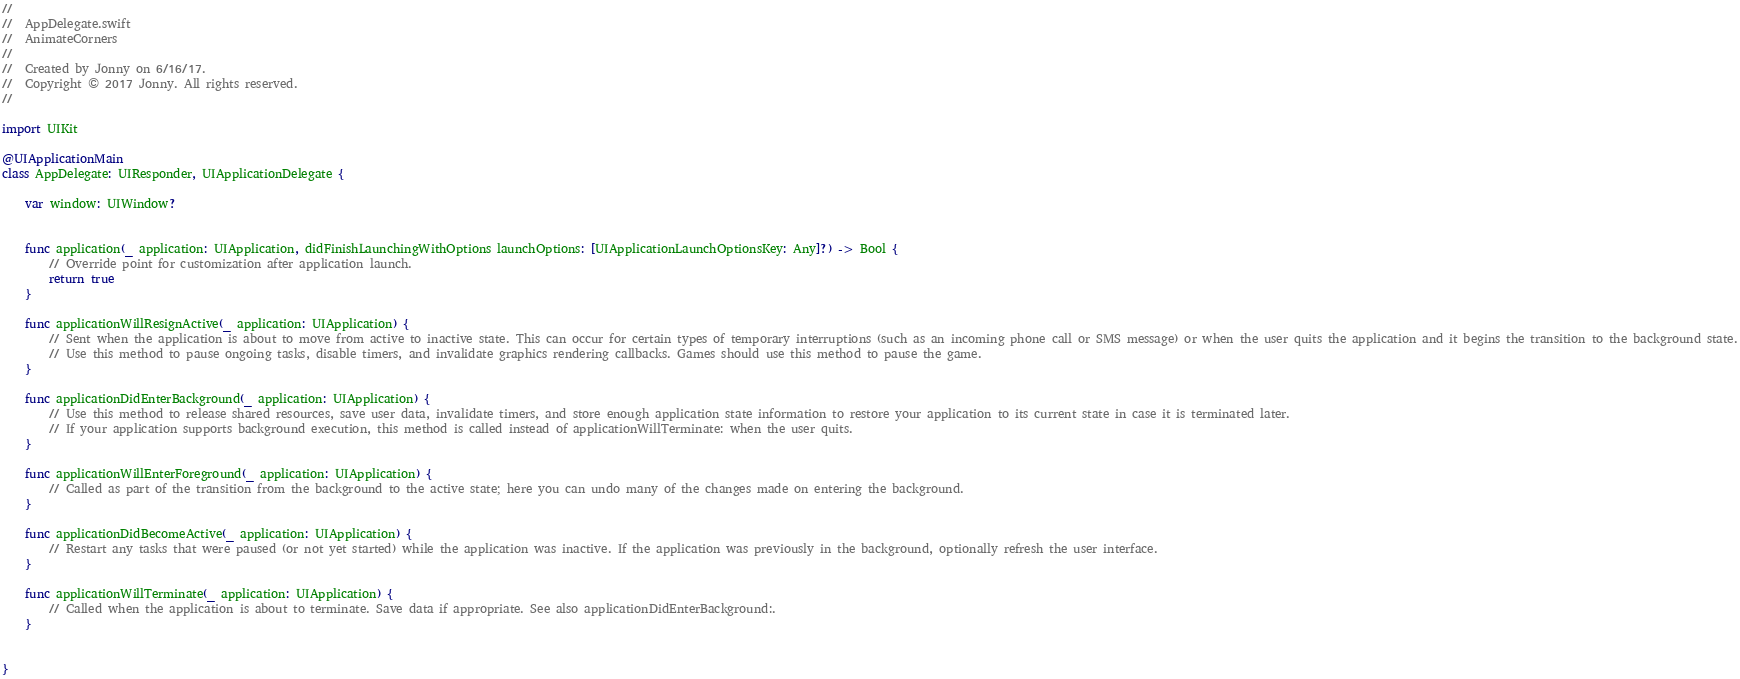<code> <loc_0><loc_0><loc_500><loc_500><_Swift_>//
//  AppDelegate.swift
//  AnimateCorners
//
//  Created by Jonny on 6/16/17.
//  Copyright © 2017 Jonny. All rights reserved.
//

import UIKit

@UIApplicationMain
class AppDelegate: UIResponder, UIApplicationDelegate {

    var window: UIWindow?


    func application(_ application: UIApplication, didFinishLaunchingWithOptions launchOptions: [UIApplicationLaunchOptionsKey: Any]?) -> Bool {
        // Override point for customization after application launch.
        return true
    }

    func applicationWillResignActive(_ application: UIApplication) {
        // Sent when the application is about to move from active to inactive state. This can occur for certain types of temporary interruptions (such as an incoming phone call or SMS message) or when the user quits the application and it begins the transition to the background state.
        // Use this method to pause ongoing tasks, disable timers, and invalidate graphics rendering callbacks. Games should use this method to pause the game.
    }

    func applicationDidEnterBackground(_ application: UIApplication) {
        // Use this method to release shared resources, save user data, invalidate timers, and store enough application state information to restore your application to its current state in case it is terminated later.
        // If your application supports background execution, this method is called instead of applicationWillTerminate: when the user quits.
    }

    func applicationWillEnterForeground(_ application: UIApplication) {
        // Called as part of the transition from the background to the active state; here you can undo many of the changes made on entering the background.
    }

    func applicationDidBecomeActive(_ application: UIApplication) {
        // Restart any tasks that were paused (or not yet started) while the application was inactive. If the application was previously in the background, optionally refresh the user interface.
    }

    func applicationWillTerminate(_ application: UIApplication) {
        // Called when the application is about to terminate. Save data if appropriate. See also applicationDidEnterBackground:.
    }


}

</code> 